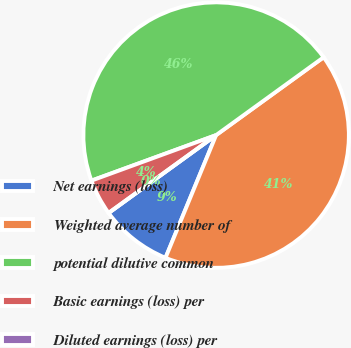<chart> <loc_0><loc_0><loc_500><loc_500><pie_chart><fcel>Net earnings (loss)<fcel>Weighted average number of<fcel>potential dilutive common<fcel>Basic earnings (loss) per<fcel>Diluted earnings (loss) per<nl><fcel>8.8%<fcel>41.2%<fcel>45.6%<fcel>4.4%<fcel>0.0%<nl></chart> 